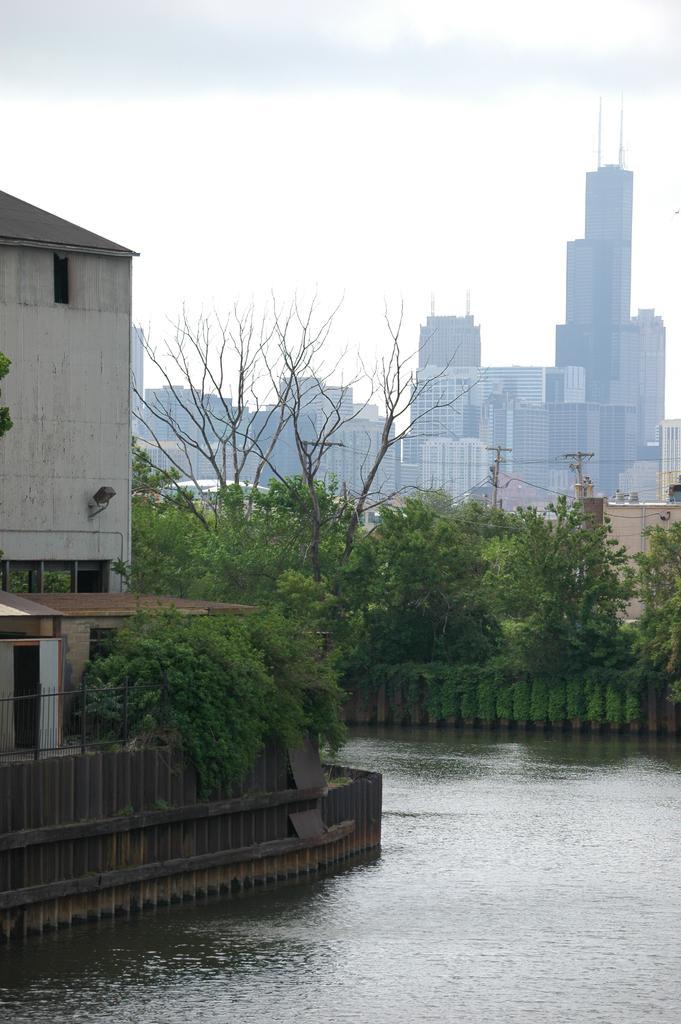Describe this image in one or two sentences. In this image in the left there is building, around it there is fence. Here there are trees. In the background there are trees, building. The sky is cloudy. On the ground there is water. 